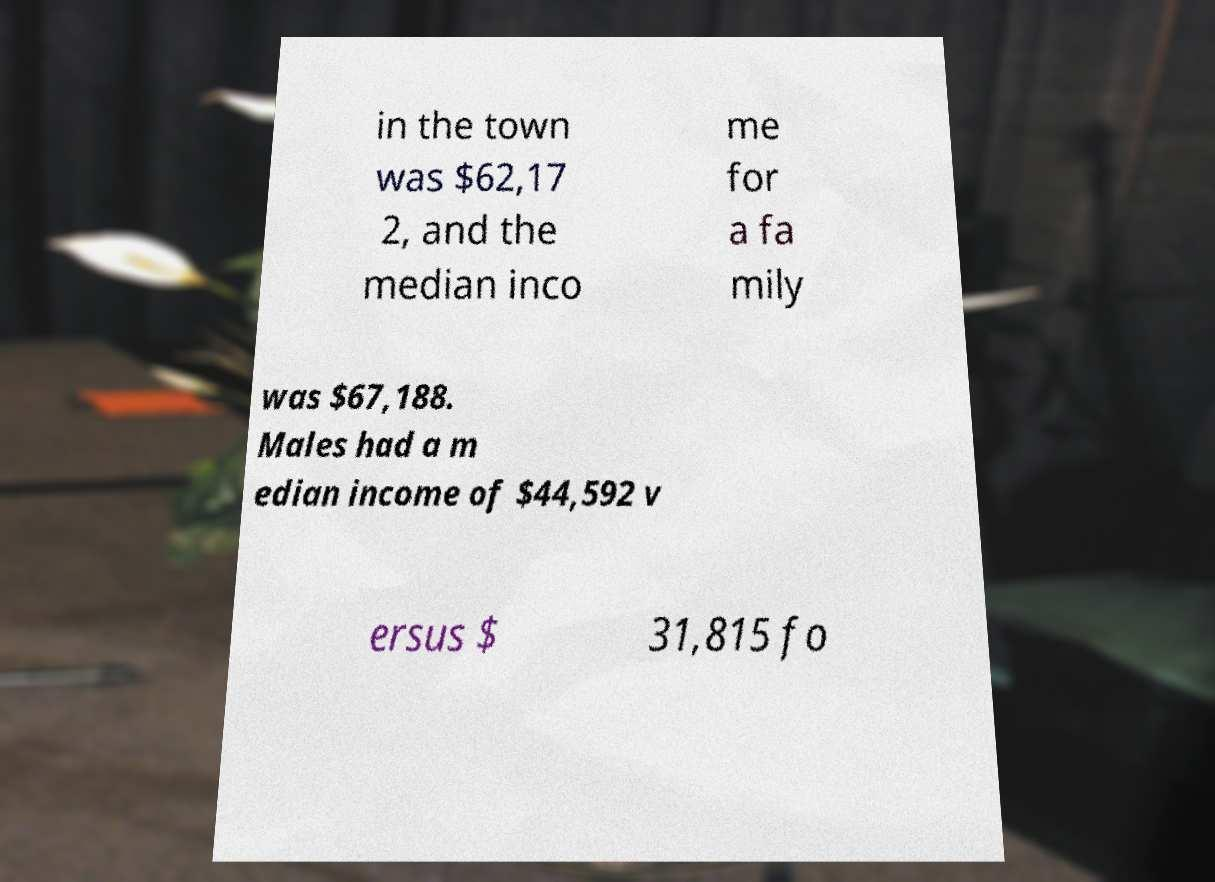Could you assist in decoding the text presented in this image and type it out clearly? in the town was $62,17 2, and the median inco me for a fa mily was $67,188. Males had a m edian income of $44,592 v ersus $ 31,815 fo 